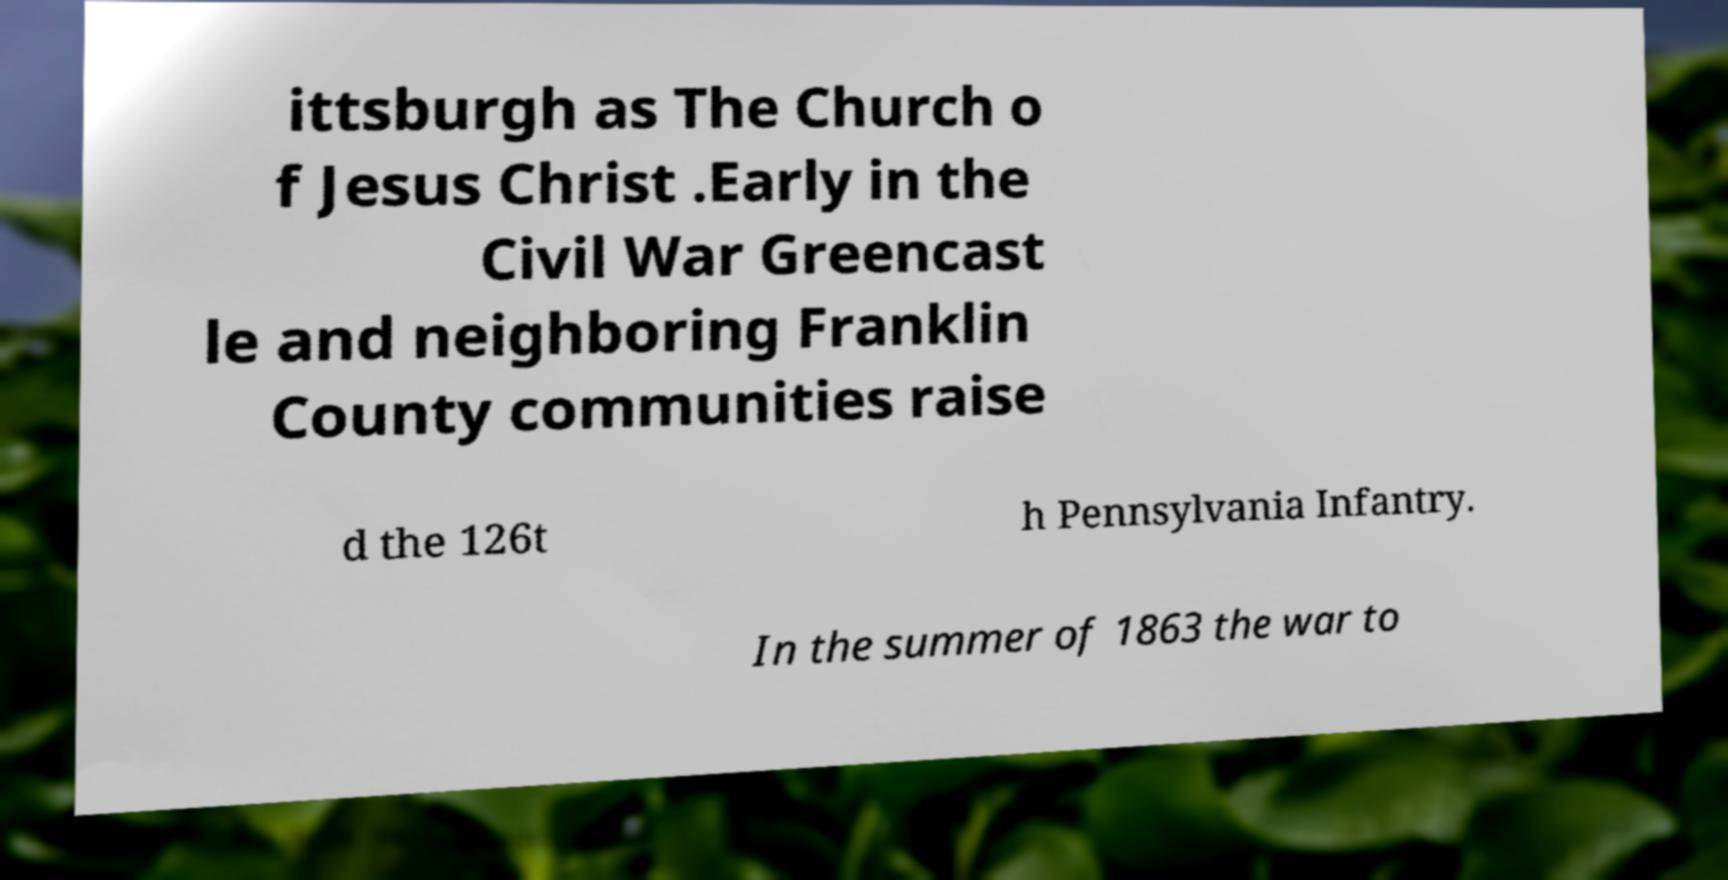Please identify and transcribe the text found in this image. ittsburgh as The Church o f Jesus Christ .Early in the Civil War Greencast le and neighboring Franklin County communities raise d the 126t h Pennsylvania Infantry. In the summer of 1863 the war to 